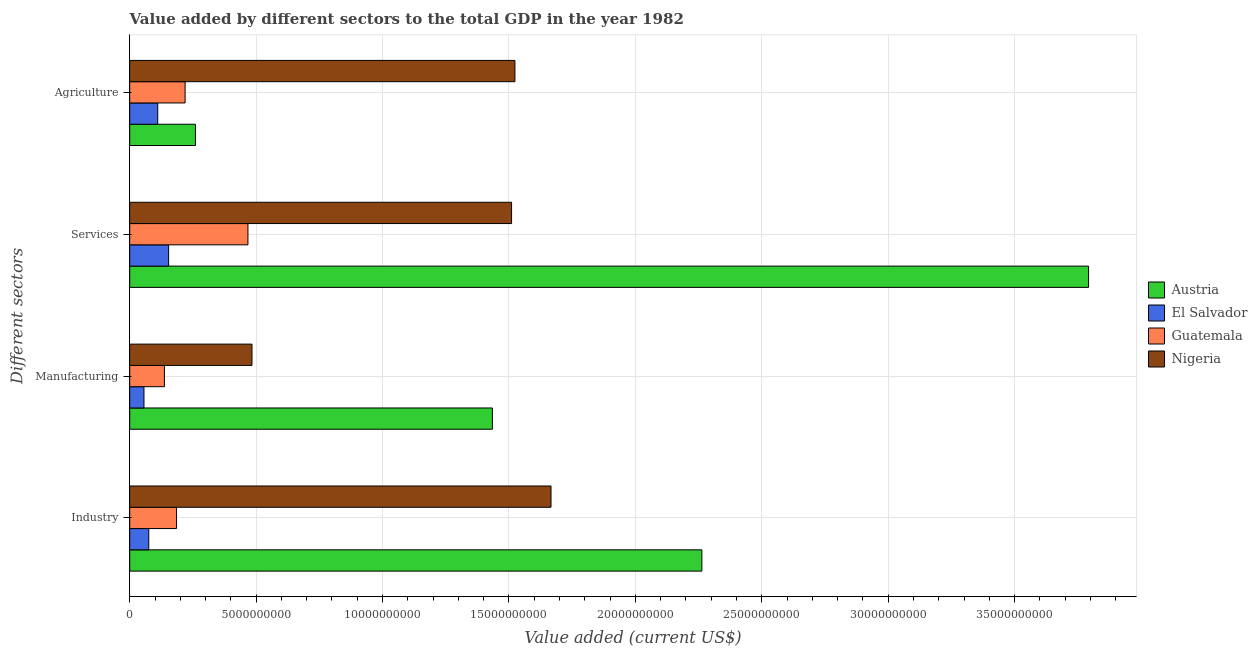Are the number of bars per tick equal to the number of legend labels?
Keep it short and to the point. Yes. Are the number of bars on each tick of the Y-axis equal?
Give a very brief answer. Yes. How many bars are there on the 1st tick from the top?
Provide a short and direct response. 4. How many bars are there on the 3rd tick from the bottom?
Your answer should be very brief. 4. What is the label of the 1st group of bars from the top?
Your answer should be compact. Agriculture. What is the value added by agricultural sector in Guatemala?
Provide a short and direct response. 2.19e+09. Across all countries, what is the maximum value added by agricultural sector?
Your answer should be very brief. 1.52e+1. Across all countries, what is the minimum value added by agricultural sector?
Your response must be concise. 1.11e+09. In which country was the value added by agricultural sector maximum?
Offer a terse response. Nigeria. In which country was the value added by agricultural sector minimum?
Provide a succinct answer. El Salvador. What is the total value added by industrial sector in the graph?
Provide a short and direct response. 4.19e+1. What is the difference between the value added by manufacturing sector in El Salvador and that in Guatemala?
Your answer should be compact. -8.09e+08. What is the difference between the value added by agricultural sector in Austria and the value added by manufacturing sector in El Salvador?
Offer a terse response. 2.04e+09. What is the average value added by agricultural sector per country?
Your answer should be very brief. 5.28e+09. What is the difference between the value added by manufacturing sector and value added by agricultural sector in El Salvador?
Your response must be concise. -5.44e+08. In how many countries, is the value added by industrial sector greater than 6000000000 US$?
Ensure brevity in your answer.  2. What is the ratio of the value added by industrial sector in Nigeria to that in Guatemala?
Offer a terse response. 9. Is the difference between the value added by industrial sector in Guatemala and Austria greater than the difference between the value added by services sector in Guatemala and Austria?
Give a very brief answer. Yes. What is the difference between the highest and the second highest value added by services sector?
Your answer should be very brief. 2.28e+1. What is the difference between the highest and the lowest value added by manufacturing sector?
Provide a short and direct response. 1.38e+1. In how many countries, is the value added by services sector greater than the average value added by services sector taken over all countries?
Your answer should be very brief. 2. Is the sum of the value added by manufacturing sector in Nigeria and Guatemala greater than the maximum value added by agricultural sector across all countries?
Make the answer very short. No. Is it the case that in every country, the sum of the value added by services sector and value added by manufacturing sector is greater than the sum of value added by industrial sector and value added by agricultural sector?
Offer a very short reply. No. What does the 1st bar from the top in Industry represents?
Ensure brevity in your answer.  Nigeria. What does the 3rd bar from the bottom in Manufacturing represents?
Your response must be concise. Guatemala. How many bars are there?
Give a very brief answer. 16. Are all the bars in the graph horizontal?
Offer a very short reply. Yes. How many countries are there in the graph?
Keep it short and to the point. 4. Are the values on the major ticks of X-axis written in scientific E-notation?
Your answer should be compact. No. Does the graph contain grids?
Provide a short and direct response. Yes. Where does the legend appear in the graph?
Ensure brevity in your answer.  Center right. How are the legend labels stacked?
Make the answer very short. Vertical. What is the title of the graph?
Give a very brief answer. Value added by different sectors to the total GDP in the year 1982. What is the label or title of the X-axis?
Your answer should be compact. Value added (current US$). What is the label or title of the Y-axis?
Your response must be concise. Different sectors. What is the Value added (current US$) in Austria in Industry?
Offer a very short reply. 2.26e+1. What is the Value added (current US$) of El Salvador in Industry?
Give a very brief answer. 7.53e+08. What is the Value added (current US$) of Guatemala in Industry?
Your answer should be very brief. 1.85e+09. What is the Value added (current US$) in Nigeria in Industry?
Give a very brief answer. 1.67e+1. What is the Value added (current US$) of Austria in Manufacturing?
Your response must be concise. 1.43e+1. What is the Value added (current US$) in El Salvador in Manufacturing?
Your response must be concise. 5.63e+08. What is the Value added (current US$) of Guatemala in Manufacturing?
Provide a short and direct response. 1.37e+09. What is the Value added (current US$) of Nigeria in Manufacturing?
Your response must be concise. 4.83e+09. What is the Value added (current US$) of Austria in Services?
Your answer should be very brief. 3.79e+1. What is the Value added (current US$) of El Salvador in Services?
Ensure brevity in your answer.  1.54e+09. What is the Value added (current US$) in Guatemala in Services?
Your answer should be very brief. 4.68e+09. What is the Value added (current US$) of Nigeria in Services?
Your answer should be compact. 1.51e+1. What is the Value added (current US$) in Austria in Agriculture?
Ensure brevity in your answer.  2.60e+09. What is the Value added (current US$) in El Salvador in Agriculture?
Your answer should be very brief. 1.11e+09. What is the Value added (current US$) of Guatemala in Agriculture?
Your answer should be compact. 2.19e+09. What is the Value added (current US$) of Nigeria in Agriculture?
Keep it short and to the point. 1.52e+1. Across all Different sectors, what is the maximum Value added (current US$) in Austria?
Give a very brief answer. 3.79e+1. Across all Different sectors, what is the maximum Value added (current US$) in El Salvador?
Your answer should be compact. 1.54e+09. Across all Different sectors, what is the maximum Value added (current US$) of Guatemala?
Offer a very short reply. 4.68e+09. Across all Different sectors, what is the maximum Value added (current US$) in Nigeria?
Your answer should be very brief. 1.67e+1. Across all Different sectors, what is the minimum Value added (current US$) in Austria?
Provide a succinct answer. 2.60e+09. Across all Different sectors, what is the minimum Value added (current US$) of El Salvador?
Offer a very short reply. 5.63e+08. Across all Different sectors, what is the minimum Value added (current US$) of Guatemala?
Your answer should be compact. 1.37e+09. Across all Different sectors, what is the minimum Value added (current US$) of Nigeria?
Provide a succinct answer. 4.83e+09. What is the total Value added (current US$) of Austria in the graph?
Make the answer very short. 7.75e+1. What is the total Value added (current US$) in El Salvador in the graph?
Your response must be concise. 3.96e+09. What is the total Value added (current US$) of Guatemala in the graph?
Your answer should be compact. 1.01e+1. What is the total Value added (current US$) of Nigeria in the graph?
Your answer should be compact. 5.18e+1. What is the difference between the Value added (current US$) of Austria in Industry and that in Manufacturing?
Your answer should be very brief. 8.29e+09. What is the difference between the Value added (current US$) in El Salvador in Industry and that in Manufacturing?
Your answer should be very brief. 1.90e+08. What is the difference between the Value added (current US$) of Guatemala in Industry and that in Manufacturing?
Provide a succinct answer. 4.78e+08. What is the difference between the Value added (current US$) in Nigeria in Industry and that in Manufacturing?
Ensure brevity in your answer.  1.18e+1. What is the difference between the Value added (current US$) of Austria in Industry and that in Services?
Provide a succinct answer. -1.53e+1. What is the difference between the Value added (current US$) of El Salvador in Industry and that in Services?
Your answer should be very brief. -7.85e+08. What is the difference between the Value added (current US$) of Guatemala in Industry and that in Services?
Your response must be concise. -2.82e+09. What is the difference between the Value added (current US$) of Nigeria in Industry and that in Services?
Your answer should be very brief. 1.56e+09. What is the difference between the Value added (current US$) in Austria in Industry and that in Agriculture?
Keep it short and to the point. 2.00e+1. What is the difference between the Value added (current US$) in El Salvador in Industry and that in Agriculture?
Keep it short and to the point. -3.55e+08. What is the difference between the Value added (current US$) in Guatemala in Industry and that in Agriculture?
Ensure brevity in your answer.  -3.39e+08. What is the difference between the Value added (current US$) in Nigeria in Industry and that in Agriculture?
Give a very brief answer. 1.43e+09. What is the difference between the Value added (current US$) in Austria in Manufacturing and that in Services?
Give a very brief answer. -2.36e+1. What is the difference between the Value added (current US$) of El Salvador in Manufacturing and that in Services?
Your response must be concise. -9.75e+08. What is the difference between the Value added (current US$) in Guatemala in Manufacturing and that in Services?
Your answer should be very brief. -3.30e+09. What is the difference between the Value added (current US$) in Nigeria in Manufacturing and that in Services?
Offer a terse response. -1.03e+1. What is the difference between the Value added (current US$) in Austria in Manufacturing and that in Agriculture?
Ensure brevity in your answer.  1.17e+1. What is the difference between the Value added (current US$) in El Salvador in Manufacturing and that in Agriculture?
Offer a terse response. -5.44e+08. What is the difference between the Value added (current US$) of Guatemala in Manufacturing and that in Agriculture?
Offer a very short reply. -8.17e+08. What is the difference between the Value added (current US$) of Nigeria in Manufacturing and that in Agriculture?
Provide a short and direct response. -1.04e+1. What is the difference between the Value added (current US$) in Austria in Services and that in Agriculture?
Give a very brief answer. 3.53e+1. What is the difference between the Value added (current US$) of El Salvador in Services and that in Agriculture?
Your response must be concise. 4.30e+08. What is the difference between the Value added (current US$) of Guatemala in Services and that in Agriculture?
Provide a short and direct response. 2.49e+09. What is the difference between the Value added (current US$) of Nigeria in Services and that in Agriculture?
Keep it short and to the point. -1.32e+08. What is the difference between the Value added (current US$) in Austria in Industry and the Value added (current US$) in El Salvador in Manufacturing?
Your response must be concise. 2.21e+1. What is the difference between the Value added (current US$) of Austria in Industry and the Value added (current US$) of Guatemala in Manufacturing?
Provide a short and direct response. 2.13e+1. What is the difference between the Value added (current US$) in Austria in Industry and the Value added (current US$) in Nigeria in Manufacturing?
Give a very brief answer. 1.78e+1. What is the difference between the Value added (current US$) in El Salvador in Industry and the Value added (current US$) in Guatemala in Manufacturing?
Your answer should be compact. -6.19e+08. What is the difference between the Value added (current US$) of El Salvador in Industry and the Value added (current US$) of Nigeria in Manufacturing?
Make the answer very short. -4.08e+09. What is the difference between the Value added (current US$) in Guatemala in Industry and the Value added (current US$) in Nigeria in Manufacturing?
Your response must be concise. -2.98e+09. What is the difference between the Value added (current US$) in Austria in Industry and the Value added (current US$) in El Salvador in Services?
Provide a short and direct response. 2.11e+1. What is the difference between the Value added (current US$) of Austria in Industry and the Value added (current US$) of Guatemala in Services?
Offer a terse response. 1.80e+1. What is the difference between the Value added (current US$) of Austria in Industry and the Value added (current US$) of Nigeria in Services?
Your answer should be very brief. 7.53e+09. What is the difference between the Value added (current US$) of El Salvador in Industry and the Value added (current US$) of Guatemala in Services?
Provide a succinct answer. -3.92e+09. What is the difference between the Value added (current US$) in El Salvador in Industry and the Value added (current US$) in Nigeria in Services?
Provide a short and direct response. -1.43e+1. What is the difference between the Value added (current US$) of Guatemala in Industry and the Value added (current US$) of Nigeria in Services?
Your answer should be very brief. -1.33e+1. What is the difference between the Value added (current US$) in Austria in Industry and the Value added (current US$) in El Salvador in Agriculture?
Offer a very short reply. 2.15e+1. What is the difference between the Value added (current US$) of Austria in Industry and the Value added (current US$) of Guatemala in Agriculture?
Give a very brief answer. 2.04e+1. What is the difference between the Value added (current US$) in Austria in Industry and the Value added (current US$) in Nigeria in Agriculture?
Your response must be concise. 7.39e+09. What is the difference between the Value added (current US$) in El Salvador in Industry and the Value added (current US$) in Guatemala in Agriculture?
Provide a short and direct response. -1.44e+09. What is the difference between the Value added (current US$) of El Salvador in Industry and the Value added (current US$) of Nigeria in Agriculture?
Offer a very short reply. -1.45e+1. What is the difference between the Value added (current US$) in Guatemala in Industry and the Value added (current US$) in Nigeria in Agriculture?
Provide a short and direct response. -1.34e+1. What is the difference between the Value added (current US$) in Austria in Manufacturing and the Value added (current US$) in El Salvador in Services?
Ensure brevity in your answer.  1.28e+1. What is the difference between the Value added (current US$) in Austria in Manufacturing and the Value added (current US$) in Guatemala in Services?
Keep it short and to the point. 9.67e+09. What is the difference between the Value added (current US$) of Austria in Manufacturing and the Value added (current US$) of Nigeria in Services?
Give a very brief answer. -7.60e+08. What is the difference between the Value added (current US$) in El Salvador in Manufacturing and the Value added (current US$) in Guatemala in Services?
Offer a very short reply. -4.11e+09. What is the difference between the Value added (current US$) of El Salvador in Manufacturing and the Value added (current US$) of Nigeria in Services?
Your response must be concise. -1.45e+1. What is the difference between the Value added (current US$) in Guatemala in Manufacturing and the Value added (current US$) in Nigeria in Services?
Your response must be concise. -1.37e+1. What is the difference between the Value added (current US$) in Austria in Manufacturing and the Value added (current US$) in El Salvador in Agriculture?
Provide a short and direct response. 1.32e+1. What is the difference between the Value added (current US$) in Austria in Manufacturing and the Value added (current US$) in Guatemala in Agriculture?
Provide a short and direct response. 1.22e+1. What is the difference between the Value added (current US$) of Austria in Manufacturing and the Value added (current US$) of Nigeria in Agriculture?
Offer a very short reply. -8.92e+08. What is the difference between the Value added (current US$) in El Salvador in Manufacturing and the Value added (current US$) in Guatemala in Agriculture?
Offer a terse response. -1.63e+09. What is the difference between the Value added (current US$) of El Salvador in Manufacturing and the Value added (current US$) of Nigeria in Agriculture?
Offer a very short reply. -1.47e+1. What is the difference between the Value added (current US$) of Guatemala in Manufacturing and the Value added (current US$) of Nigeria in Agriculture?
Ensure brevity in your answer.  -1.39e+1. What is the difference between the Value added (current US$) in Austria in Services and the Value added (current US$) in El Salvador in Agriculture?
Offer a terse response. 3.68e+1. What is the difference between the Value added (current US$) in Austria in Services and the Value added (current US$) in Guatemala in Agriculture?
Keep it short and to the point. 3.57e+1. What is the difference between the Value added (current US$) in Austria in Services and the Value added (current US$) in Nigeria in Agriculture?
Your answer should be very brief. 2.27e+1. What is the difference between the Value added (current US$) in El Salvador in Services and the Value added (current US$) in Guatemala in Agriculture?
Offer a very short reply. -6.52e+08. What is the difference between the Value added (current US$) of El Salvador in Services and the Value added (current US$) of Nigeria in Agriculture?
Offer a terse response. -1.37e+1. What is the difference between the Value added (current US$) of Guatemala in Services and the Value added (current US$) of Nigeria in Agriculture?
Provide a succinct answer. -1.06e+1. What is the average Value added (current US$) of Austria per Different sectors?
Offer a very short reply. 1.94e+1. What is the average Value added (current US$) in El Salvador per Different sectors?
Offer a very short reply. 9.91e+08. What is the average Value added (current US$) in Guatemala per Different sectors?
Your answer should be compact. 2.52e+09. What is the average Value added (current US$) in Nigeria per Different sectors?
Keep it short and to the point. 1.30e+1. What is the difference between the Value added (current US$) in Austria and Value added (current US$) in El Salvador in Industry?
Provide a succinct answer. 2.19e+1. What is the difference between the Value added (current US$) in Austria and Value added (current US$) in Guatemala in Industry?
Give a very brief answer. 2.08e+1. What is the difference between the Value added (current US$) in Austria and Value added (current US$) in Nigeria in Industry?
Your answer should be very brief. 5.97e+09. What is the difference between the Value added (current US$) of El Salvador and Value added (current US$) of Guatemala in Industry?
Your response must be concise. -1.10e+09. What is the difference between the Value added (current US$) in El Salvador and Value added (current US$) in Nigeria in Industry?
Provide a short and direct response. -1.59e+1. What is the difference between the Value added (current US$) in Guatemala and Value added (current US$) in Nigeria in Industry?
Ensure brevity in your answer.  -1.48e+1. What is the difference between the Value added (current US$) in Austria and Value added (current US$) in El Salvador in Manufacturing?
Give a very brief answer. 1.38e+1. What is the difference between the Value added (current US$) in Austria and Value added (current US$) in Guatemala in Manufacturing?
Your answer should be very brief. 1.30e+1. What is the difference between the Value added (current US$) in Austria and Value added (current US$) in Nigeria in Manufacturing?
Your answer should be very brief. 9.51e+09. What is the difference between the Value added (current US$) of El Salvador and Value added (current US$) of Guatemala in Manufacturing?
Give a very brief answer. -8.09e+08. What is the difference between the Value added (current US$) of El Salvador and Value added (current US$) of Nigeria in Manufacturing?
Give a very brief answer. -4.27e+09. What is the difference between the Value added (current US$) in Guatemala and Value added (current US$) in Nigeria in Manufacturing?
Your answer should be very brief. -3.46e+09. What is the difference between the Value added (current US$) of Austria and Value added (current US$) of El Salvador in Services?
Offer a terse response. 3.64e+1. What is the difference between the Value added (current US$) of Austria and Value added (current US$) of Guatemala in Services?
Keep it short and to the point. 3.32e+1. What is the difference between the Value added (current US$) of Austria and Value added (current US$) of Nigeria in Services?
Keep it short and to the point. 2.28e+1. What is the difference between the Value added (current US$) in El Salvador and Value added (current US$) in Guatemala in Services?
Make the answer very short. -3.14e+09. What is the difference between the Value added (current US$) in El Salvador and Value added (current US$) in Nigeria in Services?
Your answer should be compact. -1.36e+1. What is the difference between the Value added (current US$) of Guatemala and Value added (current US$) of Nigeria in Services?
Ensure brevity in your answer.  -1.04e+1. What is the difference between the Value added (current US$) in Austria and Value added (current US$) in El Salvador in Agriculture?
Provide a succinct answer. 1.49e+09. What is the difference between the Value added (current US$) of Austria and Value added (current US$) of Guatemala in Agriculture?
Make the answer very short. 4.10e+08. What is the difference between the Value added (current US$) of Austria and Value added (current US$) of Nigeria in Agriculture?
Provide a short and direct response. -1.26e+1. What is the difference between the Value added (current US$) in El Salvador and Value added (current US$) in Guatemala in Agriculture?
Provide a short and direct response. -1.08e+09. What is the difference between the Value added (current US$) of El Salvador and Value added (current US$) of Nigeria in Agriculture?
Your answer should be compact. -1.41e+1. What is the difference between the Value added (current US$) of Guatemala and Value added (current US$) of Nigeria in Agriculture?
Provide a succinct answer. -1.30e+1. What is the ratio of the Value added (current US$) in Austria in Industry to that in Manufacturing?
Make the answer very short. 1.58. What is the ratio of the Value added (current US$) of El Salvador in Industry to that in Manufacturing?
Provide a short and direct response. 1.34. What is the ratio of the Value added (current US$) in Guatemala in Industry to that in Manufacturing?
Offer a terse response. 1.35. What is the ratio of the Value added (current US$) in Nigeria in Industry to that in Manufacturing?
Ensure brevity in your answer.  3.45. What is the ratio of the Value added (current US$) of Austria in Industry to that in Services?
Keep it short and to the point. 0.6. What is the ratio of the Value added (current US$) of El Salvador in Industry to that in Services?
Your response must be concise. 0.49. What is the ratio of the Value added (current US$) in Guatemala in Industry to that in Services?
Provide a short and direct response. 0.4. What is the ratio of the Value added (current US$) in Nigeria in Industry to that in Services?
Give a very brief answer. 1.1. What is the ratio of the Value added (current US$) of Austria in Industry to that in Agriculture?
Make the answer very short. 8.7. What is the ratio of the Value added (current US$) in El Salvador in Industry to that in Agriculture?
Provide a succinct answer. 0.68. What is the ratio of the Value added (current US$) in Guatemala in Industry to that in Agriculture?
Provide a short and direct response. 0.85. What is the ratio of the Value added (current US$) of Nigeria in Industry to that in Agriculture?
Your answer should be compact. 1.09. What is the ratio of the Value added (current US$) in Austria in Manufacturing to that in Services?
Give a very brief answer. 0.38. What is the ratio of the Value added (current US$) in El Salvador in Manufacturing to that in Services?
Offer a very short reply. 0.37. What is the ratio of the Value added (current US$) of Guatemala in Manufacturing to that in Services?
Your answer should be compact. 0.29. What is the ratio of the Value added (current US$) in Nigeria in Manufacturing to that in Services?
Your answer should be very brief. 0.32. What is the ratio of the Value added (current US$) of Austria in Manufacturing to that in Agriculture?
Your response must be concise. 5.52. What is the ratio of the Value added (current US$) in El Salvador in Manufacturing to that in Agriculture?
Provide a succinct answer. 0.51. What is the ratio of the Value added (current US$) of Guatemala in Manufacturing to that in Agriculture?
Ensure brevity in your answer.  0.63. What is the ratio of the Value added (current US$) of Nigeria in Manufacturing to that in Agriculture?
Ensure brevity in your answer.  0.32. What is the ratio of the Value added (current US$) of Austria in Services to that in Agriculture?
Your answer should be very brief. 14.59. What is the ratio of the Value added (current US$) of El Salvador in Services to that in Agriculture?
Provide a short and direct response. 1.39. What is the ratio of the Value added (current US$) in Guatemala in Services to that in Agriculture?
Offer a very short reply. 2.13. What is the ratio of the Value added (current US$) of Nigeria in Services to that in Agriculture?
Keep it short and to the point. 0.99. What is the difference between the highest and the second highest Value added (current US$) in Austria?
Your response must be concise. 1.53e+1. What is the difference between the highest and the second highest Value added (current US$) of El Salvador?
Make the answer very short. 4.30e+08. What is the difference between the highest and the second highest Value added (current US$) of Guatemala?
Your answer should be compact. 2.49e+09. What is the difference between the highest and the second highest Value added (current US$) in Nigeria?
Your response must be concise. 1.43e+09. What is the difference between the highest and the lowest Value added (current US$) in Austria?
Give a very brief answer. 3.53e+1. What is the difference between the highest and the lowest Value added (current US$) of El Salvador?
Offer a terse response. 9.75e+08. What is the difference between the highest and the lowest Value added (current US$) in Guatemala?
Keep it short and to the point. 3.30e+09. What is the difference between the highest and the lowest Value added (current US$) in Nigeria?
Keep it short and to the point. 1.18e+1. 